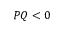Convert formula to latex. <formula><loc_0><loc_0><loc_500><loc_500>P Q < 0</formula> 